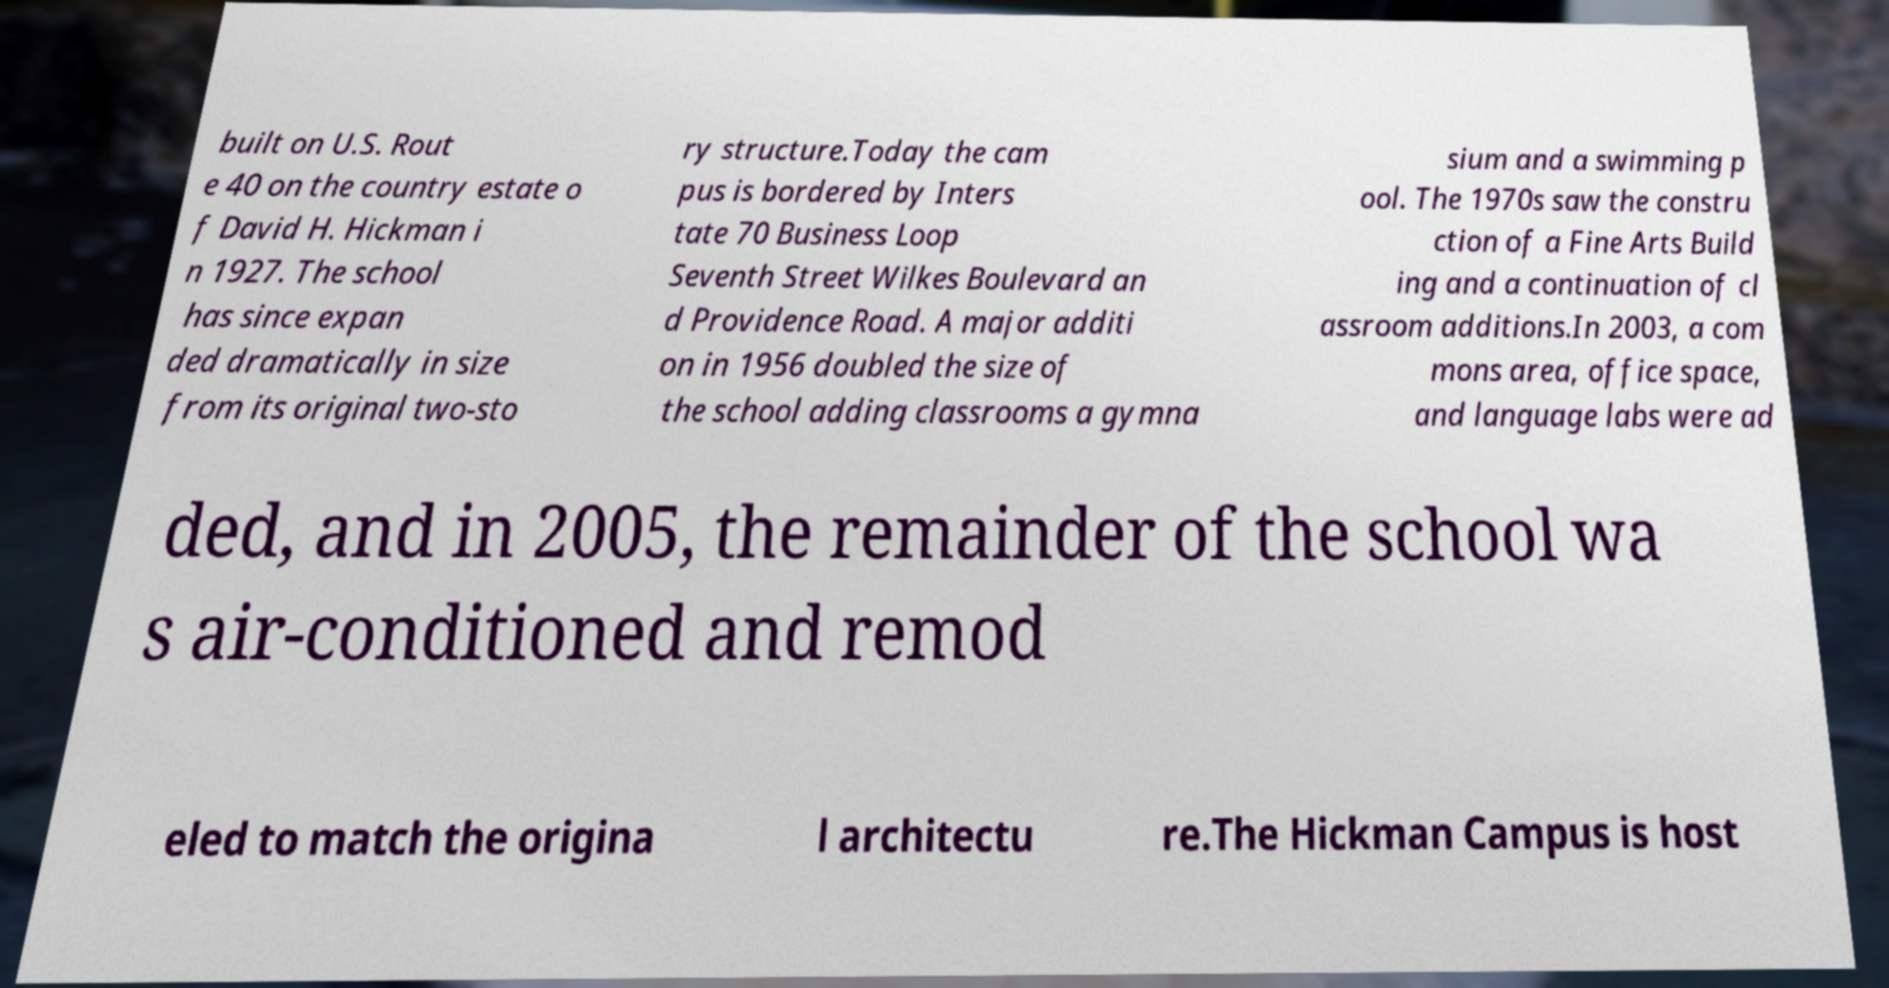Could you extract and type out the text from this image? built on U.S. Rout e 40 on the country estate o f David H. Hickman i n 1927. The school has since expan ded dramatically in size from its original two-sto ry structure.Today the cam pus is bordered by Inters tate 70 Business Loop Seventh Street Wilkes Boulevard an d Providence Road. A major additi on in 1956 doubled the size of the school adding classrooms a gymna sium and a swimming p ool. The 1970s saw the constru ction of a Fine Arts Build ing and a continuation of cl assroom additions.In 2003, a com mons area, office space, and language labs were ad ded, and in 2005, the remainder of the school wa s air-conditioned and remod eled to match the origina l architectu re.The Hickman Campus is host 